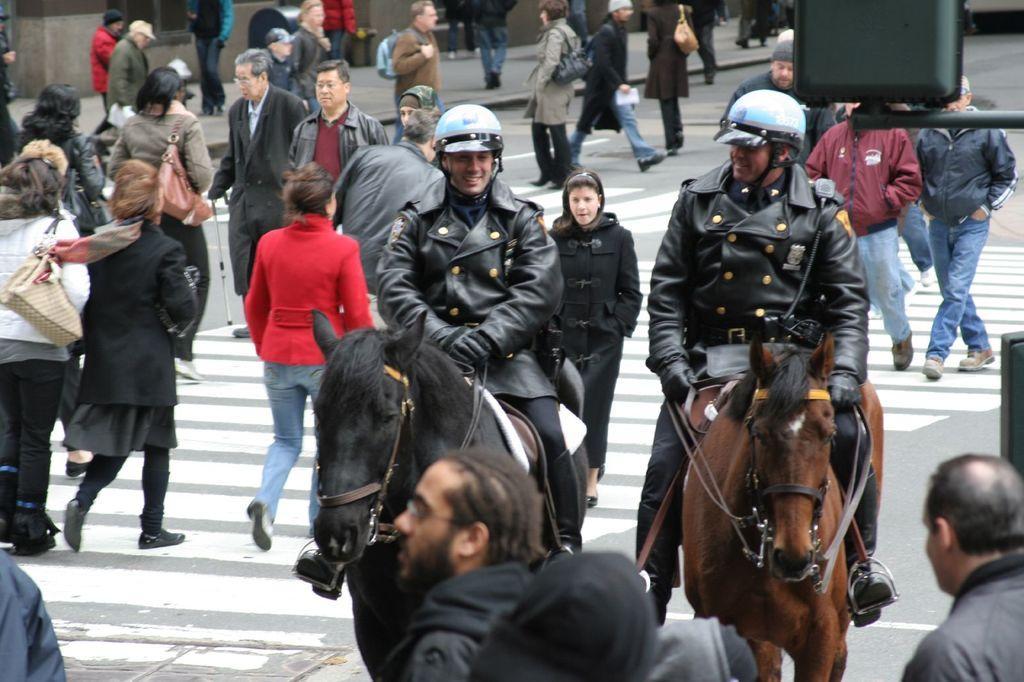How would you summarize this image in a sentence or two? In this image there are a group of people some of them are standing and some of them are walking, on the right side there are two persons who are sitting on a horse and they are smiling. On the top of the right corner there is one board. 